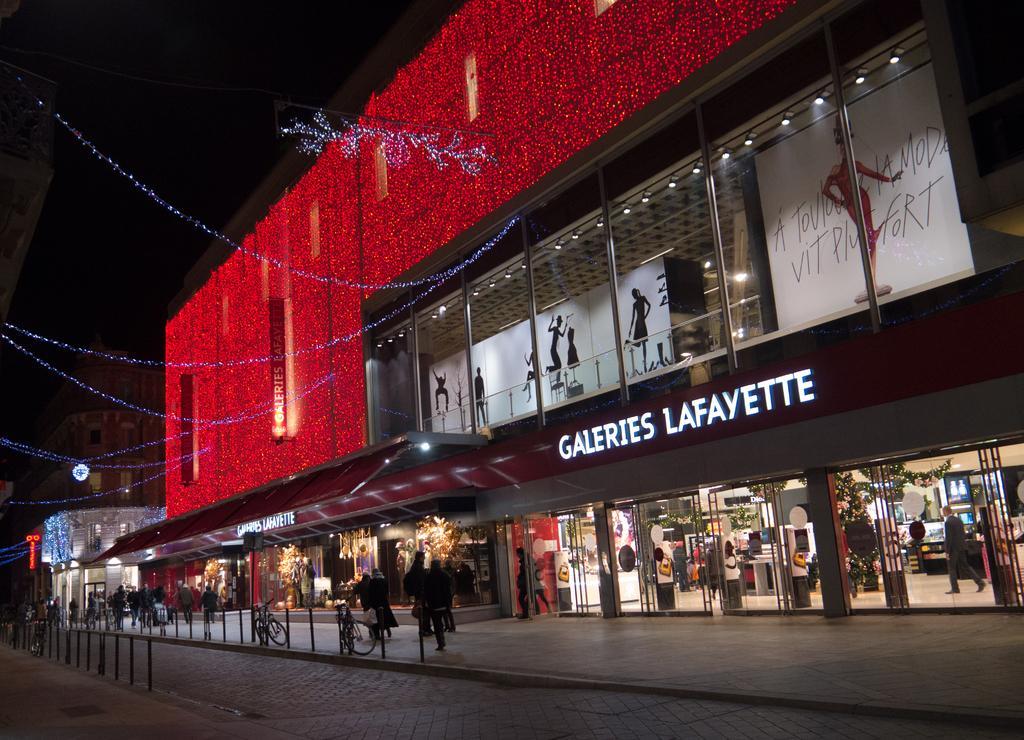Can you describe this image briefly? In this picture we can see few buildings, hoardings and lights, in front of the building we can find few metal rods, bicycles and group of people. 